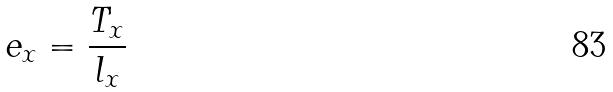<formula> <loc_0><loc_0><loc_500><loc_500>e _ { x } = \frac { T _ { x } } { l _ { x } }</formula> 